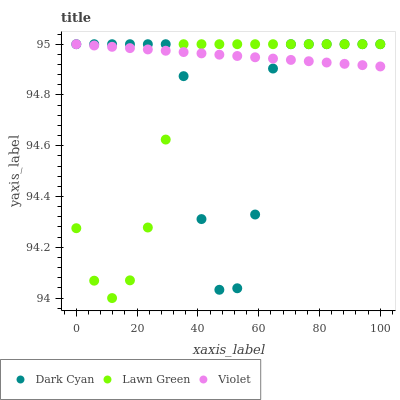Does Lawn Green have the minimum area under the curve?
Answer yes or no. Yes. Does Violet have the maximum area under the curve?
Answer yes or no. Yes. Does Violet have the minimum area under the curve?
Answer yes or no. No. Does Lawn Green have the maximum area under the curve?
Answer yes or no. No. Is Violet the smoothest?
Answer yes or no. Yes. Is Dark Cyan the roughest?
Answer yes or no. Yes. Is Lawn Green the smoothest?
Answer yes or no. No. Is Lawn Green the roughest?
Answer yes or no. No. Does Lawn Green have the lowest value?
Answer yes or no. Yes. Does Violet have the lowest value?
Answer yes or no. No. Does Violet have the highest value?
Answer yes or no. Yes. Does Lawn Green intersect Dark Cyan?
Answer yes or no. Yes. Is Lawn Green less than Dark Cyan?
Answer yes or no. No. Is Lawn Green greater than Dark Cyan?
Answer yes or no. No. 